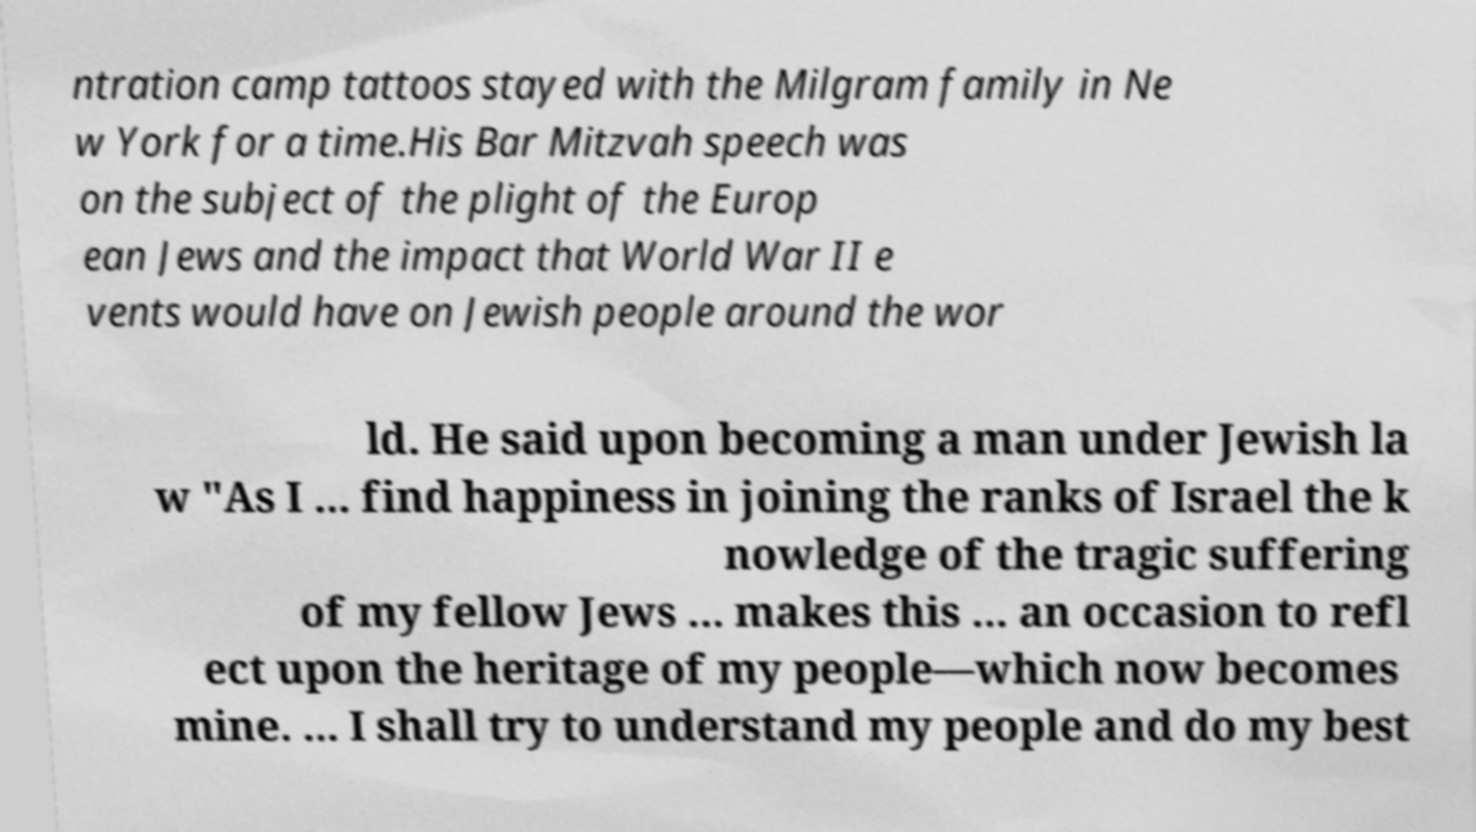Can you accurately transcribe the text from the provided image for me? ntration camp tattoos stayed with the Milgram family in Ne w York for a time.His Bar Mitzvah speech was on the subject of the plight of the Europ ean Jews and the impact that World War II e vents would have on Jewish people around the wor ld. He said upon becoming a man under Jewish la w "As I ... find happiness in joining the ranks of Israel the k nowledge of the tragic suffering of my fellow Jews ... makes this ... an occasion to refl ect upon the heritage of my people—which now becomes mine. ... I shall try to understand my people and do my best 